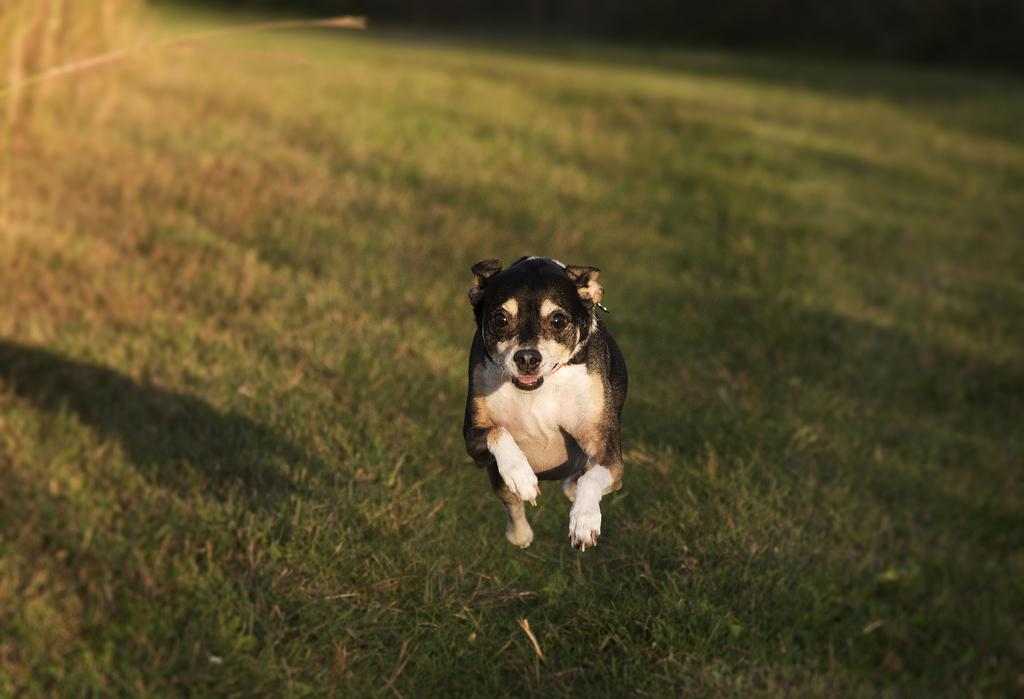What type of animal is in the image? There is a dog in the image. What colors can be seen on the dog? The dog is black and white in color. What action is the dog performing in the image? The dog is jumping into the air. What type of terrain is visible in the background of the image? There is grass visible in the background of the image. What type of oil is being pumped in the image? There is no oil or pump present in the image; it features a dog jumping into the air with grass in the background. 